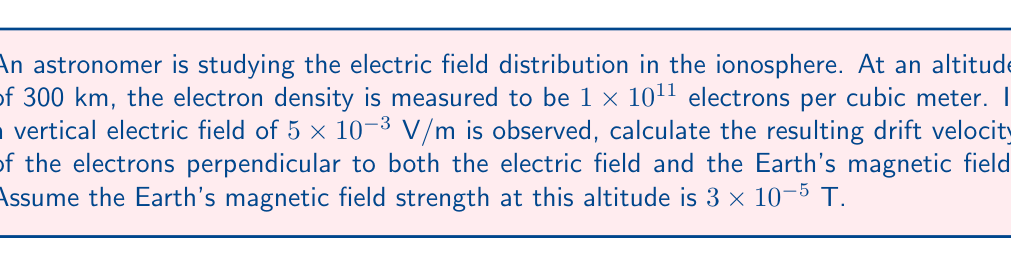What is the answer to this math problem? To solve this problem, we'll use the concept of $\mathbf{E} \times \mathbf{B}$ drift in plasma physics. The steps are as follows:

1) The drift velocity $\mathbf{v}_d$ for charged particles in crossed electric and magnetic fields is given by:

   $$\mathbf{v}_d = \frac{\mathbf{E} \times \mathbf{B}}{B^2}$$

2) We have:
   $E = 5 \times 10^{-3}$ V/m (vertical)
   $B = 3 \times 10^{-5}$ T

3) The drift velocity will be perpendicular to both $\mathbf{E}$ and $\mathbf{B}$. The magnitude is:

   $$v_d = \frac{E}{B} = \frac{5 \times 10^{-3}}{3 \times 10^{-5}} = 166.67 \text{ m/s}$$

4) To convert to km/h:
   
   $$v_d = 166.67 \text{ m/s} \times \frac{3600 \text{ s}}{1 \text{ h}} \times \frac{1 \text{ km}}{1000 \text{ m}} = 600 \text{ km/h}$$

Note: The electron density, while given in the problem, is not needed for this calculation as the drift velocity is independent of particle mass and charge.
Answer: 600 km/h 